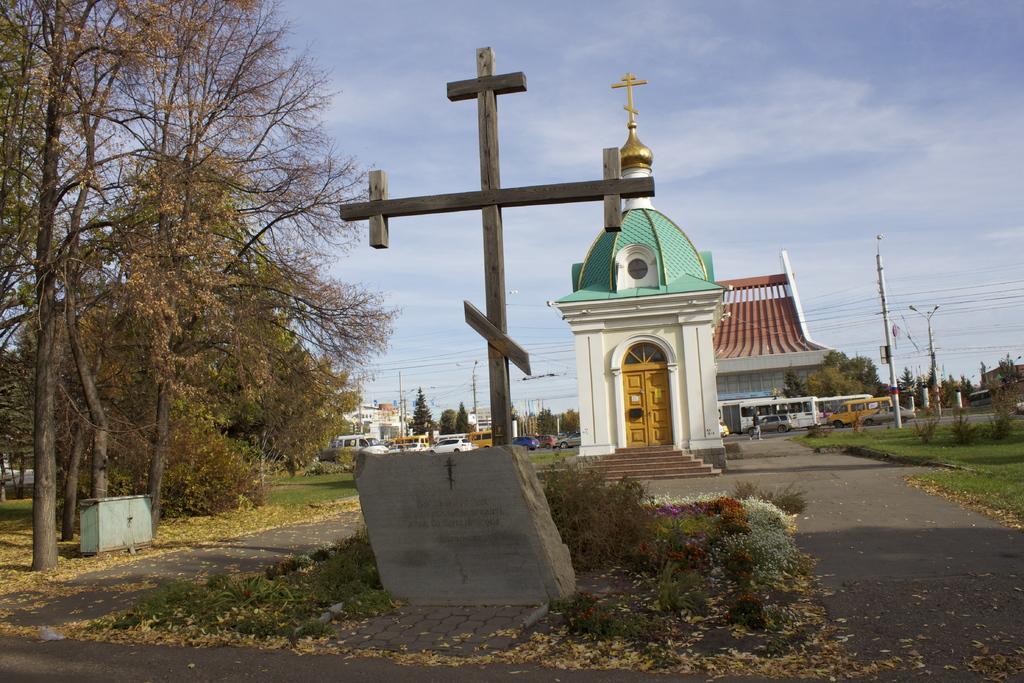Could you give a brief overview of what you see in this image? In this picture, it seems like a plus pole and a stone in the foreground area of the image, there are houses, a church, trees, vehicles, poles and the sky in the background. 